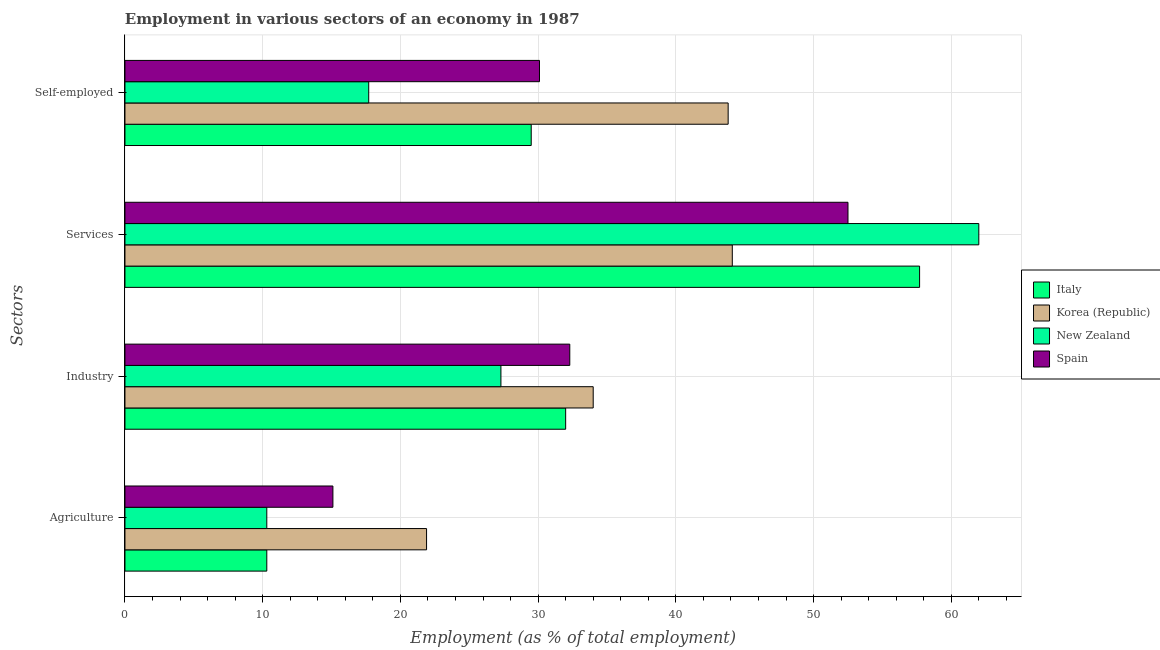Are the number of bars per tick equal to the number of legend labels?
Your answer should be compact. Yes. Are the number of bars on each tick of the Y-axis equal?
Your answer should be compact. Yes. How many bars are there on the 3rd tick from the top?
Provide a succinct answer. 4. How many bars are there on the 3rd tick from the bottom?
Offer a very short reply. 4. What is the label of the 3rd group of bars from the top?
Keep it short and to the point. Industry. What is the percentage of self employed workers in Italy?
Provide a short and direct response. 29.5. Across all countries, what is the maximum percentage of workers in services?
Ensure brevity in your answer.  62. Across all countries, what is the minimum percentage of self employed workers?
Your answer should be very brief. 17.7. In which country was the percentage of self employed workers maximum?
Your answer should be very brief. Korea (Republic). In which country was the percentage of workers in industry minimum?
Your answer should be very brief. New Zealand. What is the total percentage of workers in agriculture in the graph?
Keep it short and to the point. 57.6. What is the difference between the percentage of self employed workers in New Zealand and that in Italy?
Your answer should be very brief. -11.8. What is the difference between the percentage of workers in services in Korea (Republic) and the percentage of workers in agriculture in New Zealand?
Make the answer very short. 33.8. What is the average percentage of workers in agriculture per country?
Provide a succinct answer. 14.4. What is the difference between the percentage of self employed workers and percentage of workers in agriculture in Italy?
Keep it short and to the point. 19.2. In how many countries, is the percentage of workers in industry greater than 14 %?
Your answer should be compact. 4. What is the ratio of the percentage of self employed workers in New Zealand to that in Korea (Republic)?
Give a very brief answer. 0.4. Is the difference between the percentage of self employed workers in Italy and Korea (Republic) greater than the difference between the percentage of workers in services in Italy and Korea (Republic)?
Provide a short and direct response. No. What is the difference between the highest and the second highest percentage of workers in services?
Offer a terse response. 4.3. What is the difference between the highest and the lowest percentage of self employed workers?
Ensure brevity in your answer.  26.1. In how many countries, is the percentage of workers in services greater than the average percentage of workers in services taken over all countries?
Give a very brief answer. 2. Is the sum of the percentage of self employed workers in Spain and Italy greater than the maximum percentage of workers in industry across all countries?
Keep it short and to the point. Yes. What does the 4th bar from the top in Services represents?
Offer a very short reply. Italy. What does the 3rd bar from the bottom in Services represents?
Ensure brevity in your answer.  New Zealand. How many bars are there?
Your answer should be compact. 16. Are all the bars in the graph horizontal?
Make the answer very short. Yes. Are the values on the major ticks of X-axis written in scientific E-notation?
Offer a very short reply. No. Does the graph contain grids?
Ensure brevity in your answer.  Yes. Where does the legend appear in the graph?
Provide a succinct answer. Center right. How many legend labels are there?
Ensure brevity in your answer.  4. What is the title of the graph?
Your answer should be very brief. Employment in various sectors of an economy in 1987. What is the label or title of the X-axis?
Provide a short and direct response. Employment (as % of total employment). What is the label or title of the Y-axis?
Offer a terse response. Sectors. What is the Employment (as % of total employment) of Italy in Agriculture?
Ensure brevity in your answer.  10.3. What is the Employment (as % of total employment) in Korea (Republic) in Agriculture?
Offer a terse response. 21.9. What is the Employment (as % of total employment) in New Zealand in Agriculture?
Keep it short and to the point. 10.3. What is the Employment (as % of total employment) of Spain in Agriculture?
Provide a short and direct response. 15.1. What is the Employment (as % of total employment) in Italy in Industry?
Give a very brief answer. 32. What is the Employment (as % of total employment) in Korea (Republic) in Industry?
Offer a terse response. 34. What is the Employment (as % of total employment) of New Zealand in Industry?
Make the answer very short. 27.3. What is the Employment (as % of total employment) of Spain in Industry?
Your answer should be compact. 32.3. What is the Employment (as % of total employment) in Italy in Services?
Ensure brevity in your answer.  57.7. What is the Employment (as % of total employment) of Korea (Republic) in Services?
Ensure brevity in your answer.  44.1. What is the Employment (as % of total employment) in Spain in Services?
Ensure brevity in your answer.  52.5. What is the Employment (as % of total employment) in Italy in Self-employed?
Make the answer very short. 29.5. What is the Employment (as % of total employment) of Korea (Republic) in Self-employed?
Ensure brevity in your answer.  43.8. What is the Employment (as % of total employment) of New Zealand in Self-employed?
Provide a short and direct response. 17.7. What is the Employment (as % of total employment) of Spain in Self-employed?
Make the answer very short. 30.1. Across all Sectors, what is the maximum Employment (as % of total employment) in Italy?
Offer a terse response. 57.7. Across all Sectors, what is the maximum Employment (as % of total employment) of Korea (Republic)?
Your answer should be very brief. 44.1. Across all Sectors, what is the maximum Employment (as % of total employment) of New Zealand?
Give a very brief answer. 62. Across all Sectors, what is the maximum Employment (as % of total employment) in Spain?
Give a very brief answer. 52.5. Across all Sectors, what is the minimum Employment (as % of total employment) of Italy?
Your response must be concise. 10.3. Across all Sectors, what is the minimum Employment (as % of total employment) of Korea (Republic)?
Provide a short and direct response. 21.9. Across all Sectors, what is the minimum Employment (as % of total employment) of New Zealand?
Your response must be concise. 10.3. Across all Sectors, what is the minimum Employment (as % of total employment) in Spain?
Offer a very short reply. 15.1. What is the total Employment (as % of total employment) of Italy in the graph?
Give a very brief answer. 129.5. What is the total Employment (as % of total employment) in Korea (Republic) in the graph?
Make the answer very short. 143.8. What is the total Employment (as % of total employment) in New Zealand in the graph?
Offer a very short reply. 117.3. What is the total Employment (as % of total employment) in Spain in the graph?
Your answer should be very brief. 130. What is the difference between the Employment (as % of total employment) of Italy in Agriculture and that in Industry?
Offer a very short reply. -21.7. What is the difference between the Employment (as % of total employment) of Korea (Republic) in Agriculture and that in Industry?
Make the answer very short. -12.1. What is the difference between the Employment (as % of total employment) in New Zealand in Agriculture and that in Industry?
Offer a terse response. -17. What is the difference between the Employment (as % of total employment) of Spain in Agriculture and that in Industry?
Your answer should be very brief. -17.2. What is the difference between the Employment (as % of total employment) of Italy in Agriculture and that in Services?
Give a very brief answer. -47.4. What is the difference between the Employment (as % of total employment) in Korea (Republic) in Agriculture and that in Services?
Ensure brevity in your answer.  -22.2. What is the difference between the Employment (as % of total employment) of New Zealand in Agriculture and that in Services?
Keep it short and to the point. -51.7. What is the difference between the Employment (as % of total employment) in Spain in Agriculture and that in Services?
Provide a short and direct response. -37.4. What is the difference between the Employment (as % of total employment) of Italy in Agriculture and that in Self-employed?
Keep it short and to the point. -19.2. What is the difference between the Employment (as % of total employment) of Korea (Republic) in Agriculture and that in Self-employed?
Offer a very short reply. -21.9. What is the difference between the Employment (as % of total employment) of Spain in Agriculture and that in Self-employed?
Keep it short and to the point. -15. What is the difference between the Employment (as % of total employment) in Italy in Industry and that in Services?
Offer a terse response. -25.7. What is the difference between the Employment (as % of total employment) in Korea (Republic) in Industry and that in Services?
Ensure brevity in your answer.  -10.1. What is the difference between the Employment (as % of total employment) in New Zealand in Industry and that in Services?
Offer a terse response. -34.7. What is the difference between the Employment (as % of total employment) in Spain in Industry and that in Services?
Offer a very short reply. -20.2. What is the difference between the Employment (as % of total employment) in Korea (Republic) in Industry and that in Self-employed?
Offer a terse response. -9.8. What is the difference between the Employment (as % of total employment) of Spain in Industry and that in Self-employed?
Give a very brief answer. 2.2. What is the difference between the Employment (as % of total employment) of Italy in Services and that in Self-employed?
Make the answer very short. 28.2. What is the difference between the Employment (as % of total employment) of Korea (Republic) in Services and that in Self-employed?
Your response must be concise. 0.3. What is the difference between the Employment (as % of total employment) in New Zealand in Services and that in Self-employed?
Give a very brief answer. 44.3. What is the difference between the Employment (as % of total employment) of Spain in Services and that in Self-employed?
Provide a short and direct response. 22.4. What is the difference between the Employment (as % of total employment) of Italy in Agriculture and the Employment (as % of total employment) of Korea (Republic) in Industry?
Make the answer very short. -23.7. What is the difference between the Employment (as % of total employment) in Korea (Republic) in Agriculture and the Employment (as % of total employment) in New Zealand in Industry?
Your answer should be compact. -5.4. What is the difference between the Employment (as % of total employment) in New Zealand in Agriculture and the Employment (as % of total employment) in Spain in Industry?
Provide a succinct answer. -22. What is the difference between the Employment (as % of total employment) of Italy in Agriculture and the Employment (as % of total employment) of Korea (Republic) in Services?
Provide a short and direct response. -33.8. What is the difference between the Employment (as % of total employment) in Italy in Agriculture and the Employment (as % of total employment) in New Zealand in Services?
Provide a short and direct response. -51.7. What is the difference between the Employment (as % of total employment) in Italy in Agriculture and the Employment (as % of total employment) in Spain in Services?
Your answer should be very brief. -42.2. What is the difference between the Employment (as % of total employment) in Korea (Republic) in Agriculture and the Employment (as % of total employment) in New Zealand in Services?
Offer a very short reply. -40.1. What is the difference between the Employment (as % of total employment) of Korea (Republic) in Agriculture and the Employment (as % of total employment) of Spain in Services?
Your answer should be compact. -30.6. What is the difference between the Employment (as % of total employment) in New Zealand in Agriculture and the Employment (as % of total employment) in Spain in Services?
Offer a terse response. -42.2. What is the difference between the Employment (as % of total employment) in Italy in Agriculture and the Employment (as % of total employment) in Korea (Republic) in Self-employed?
Give a very brief answer. -33.5. What is the difference between the Employment (as % of total employment) in Italy in Agriculture and the Employment (as % of total employment) in New Zealand in Self-employed?
Offer a terse response. -7.4. What is the difference between the Employment (as % of total employment) of Italy in Agriculture and the Employment (as % of total employment) of Spain in Self-employed?
Keep it short and to the point. -19.8. What is the difference between the Employment (as % of total employment) of Korea (Republic) in Agriculture and the Employment (as % of total employment) of New Zealand in Self-employed?
Keep it short and to the point. 4.2. What is the difference between the Employment (as % of total employment) in Korea (Republic) in Agriculture and the Employment (as % of total employment) in Spain in Self-employed?
Your answer should be very brief. -8.2. What is the difference between the Employment (as % of total employment) of New Zealand in Agriculture and the Employment (as % of total employment) of Spain in Self-employed?
Your answer should be compact. -19.8. What is the difference between the Employment (as % of total employment) in Italy in Industry and the Employment (as % of total employment) in Korea (Republic) in Services?
Offer a very short reply. -12.1. What is the difference between the Employment (as % of total employment) in Italy in Industry and the Employment (as % of total employment) in New Zealand in Services?
Your answer should be very brief. -30. What is the difference between the Employment (as % of total employment) of Italy in Industry and the Employment (as % of total employment) of Spain in Services?
Make the answer very short. -20.5. What is the difference between the Employment (as % of total employment) in Korea (Republic) in Industry and the Employment (as % of total employment) in New Zealand in Services?
Provide a succinct answer. -28. What is the difference between the Employment (as % of total employment) in Korea (Republic) in Industry and the Employment (as % of total employment) in Spain in Services?
Your response must be concise. -18.5. What is the difference between the Employment (as % of total employment) in New Zealand in Industry and the Employment (as % of total employment) in Spain in Services?
Your response must be concise. -25.2. What is the difference between the Employment (as % of total employment) in Italy in Industry and the Employment (as % of total employment) in Korea (Republic) in Self-employed?
Provide a short and direct response. -11.8. What is the difference between the Employment (as % of total employment) in Italy in Industry and the Employment (as % of total employment) in New Zealand in Self-employed?
Your answer should be very brief. 14.3. What is the difference between the Employment (as % of total employment) in Italy in Industry and the Employment (as % of total employment) in Spain in Self-employed?
Offer a terse response. 1.9. What is the difference between the Employment (as % of total employment) in Korea (Republic) in Industry and the Employment (as % of total employment) in New Zealand in Self-employed?
Ensure brevity in your answer.  16.3. What is the difference between the Employment (as % of total employment) of Korea (Republic) in Industry and the Employment (as % of total employment) of Spain in Self-employed?
Your answer should be compact. 3.9. What is the difference between the Employment (as % of total employment) of New Zealand in Industry and the Employment (as % of total employment) of Spain in Self-employed?
Keep it short and to the point. -2.8. What is the difference between the Employment (as % of total employment) in Italy in Services and the Employment (as % of total employment) in Korea (Republic) in Self-employed?
Provide a short and direct response. 13.9. What is the difference between the Employment (as % of total employment) in Italy in Services and the Employment (as % of total employment) in Spain in Self-employed?
Your answer should be compact. 27.6. What is the difference between the Employment (as % of total employment) of Korea (Republic) in Services and the Employment (as % of total employment) of New Zealand in Self-employed?
Your answer should be very brief. 26.4. What is the difference between the Employment (as % of total employment) in Korea (Republic) in Services and the Employment (as % of total employment) in Spain in Self-employed?
Give a very brief answer. 14. What is the difference between the Employment (as % of total employment) in New Zealand in Services and the Employment (as % of total employment) in Spain in Self-employed?
Your response must be concise. 31.9. What is the average Employment (as % of total employment) in Italy per Sectors?
Offer a terse response. 32.38. What is the average Employment (as % of total employment) of Korea (Republic) per Sectors?
Ensure brevity in your answer.  35.95. What is the average Employment (as % of total employment) in New Zealand per Sectors?
Offer a very short reply. 29.32. What is the average Employment (as % of total employment) in Spain per Sectors?
Your answer should be compact. 32.5. What is the difference between the Employment (as % of total employment) of Italy and Employment (as % of total employment) of Korea (Republic) in Agriculture?
Ensure brevity in your answer.  -11.6. What is the difference between the Employment (as % of total employment) of Italy and Employment (as % of total employment) of New Zealand in Agriculture?
Keep it short and to the point. 0. What is the difference between the Employment (as % of total employment) in Korea (Republic) and Employment (as % of total employment) in New Zealand in Agriculture?
Keep it short and to the point. 11.6. What is the difference between the Employment (as % of total employment) in Korea (Republic) and Employment (as % of total employment) in Spain in Agriculture?
Ensure brevity in your answer.  6.8. What is the difference between the Employment (as % of total employment) in New Zealand and Employment (as % of total employment) in Spain in Agriculture?
Give a very brief answer. -4.8. What is the difference between the Employment (as % of total employment) in Italy and Employment (as % of total employment) in New Zealand in Industry?
Offer a very short reply. 4.7. What is the difference between the Employment (as % of total employment) of Italy and Employment (as % of total employment) of Spain in Industry?
Provide a succinct answer. -0.3. What is the difference between the Employment (as % of total employment) in Korea (Republic) and Employment (as % of total employment) in New Zealand in Industry?
Your answer should be very brief. 6.7. What is the difference between the Employment (as % of total employment) in New Zealand and Employment (as % of total employment) in Spain in Industry?
Offer a very short reply. -5. What is the difference between the Employment (as % of total employment) of Italy and Employment (as % of total employment) of Korea (Republic) in Services?
Offer a very short reply. 13.6. What is the difference between the Employment (as % of total employment) in Italy and Employment (as % of total employment) in Spain in Services?
Offer a very short reply. 5.2. What is the difference between the Employment (as % of total employment) of Korea (Republic) and Employment (as % of total employment) of New Zealand in Services?
Your answer should be compact. -17.9. What is the difference between the Employment (as % of total employment) in Korea (Republic) and Employment (as % of total employment) in Spain in Services?
Your response must be concise. -8.4. What is the difference between the Employment (as % of total employment) in Italy and Employment (as % of total employment) in Korea (Republic) in Self-employed?
Make the answer very short. -14.3. What is the difference between the Employment (as % of total employment) in Italy and Employment (as % of total employment) in New Zealand in Self-employed?
Give a very brief answer. 11.8. What is the difference between the Employment (as % of total employment) in Italy and Employment (as % of total employment) in Spain in Self-employed?
Ensure brevity in your answer.  -0.6. What is the difference between the Employment (as % of total employment) in Korea (Republic) and Employment (as % of total employment) in New Zealand in Self-employed?
Your answer should be compact. 26.1. What is the difference between the Employment (as % of total employment) of Korea (Republic) and Employment (as % of total employment) of Spain in Self-employed?
Your answer should be very brief. 13.7. What is the ratio of the Employment (as % of total employment) of Italy in Agriculture to that in Industry?
Ensure brevity in your answer.  0.32. What is the ratio of the Employment (as % of total employment) of Korea (Republic) in Agriculture to that in Industry?
Ensure brevity in your answer.  0.64. What is the ratio of the Employment (as % of total employment) of New Zealand in Agriculture to that in Industry?
Your response must be concise. 0.38. What is the ratio of the Employment (as % of total employment) in Spain in Agriculture to that in Industry?
Give a very brief answer. 0.47. What is the ratio of the Employment (as % of total employment) of Italy in Agriculture to that in Services?
Your answer should be very brief. 0.18. What is the ratio of the Employment (as % of total employment) of Korea (Republic) in Agriculture to that in Services?
Provide a succinct answer. 0.5. What is the ratio of the Employment (as % of total employment) in New Zealand in Agriculture to that in Services?
Provide a short and direct response. 0.17. What is the ratio of the Employment (as % of total employment) in Spain in Agriculture to that in Services?
Your response must be concise. 0.29. What is the ratio of the Employment (as % of total employment) in Italy in Agriculture to that in Self-employed?
Make the answer very short. 0.35. What is the ratio of the Employment (as % of total employment) in Korea (Republic) in Agriculture to that in Self-employed?
Your answer should be compact. 0.5. What is the ratio of the Employment (as % of total employment) in New Zealand in Agriculture to that in Self-employed?
Your response must be concise. 0.58. What is the ratio of the Employment (as % of total employment) in Spain in Agriculture to that in Self-employed?
Provide a succinct answer. 0.5. What is the ratio of the Employment (as % of total employment) of Italy in Industry to that in Services?
Your response must be concise. 0.55. What is the ratio of the Employment (as % of total employment) of Korea (Republic) in Industry to that in Services?
Your answer should be compact. 0.77. What is the ratio of the Employment (as % of total employment) of New Zealand in Industry to that in Services?
Provide a succinct answer. 0.44. What is the ratio of the Employment (as % of total employment) of Spain in Industry to that in Services?
Ensure brevity in your answer.  0.62. What is the ratio of the Employment (as % of total employment) of Italy in Industry to that in Self-employed?
Provide a succinct answer. 1.08. What is the ratio of the Employment (as % of total employment) of Korea (Republic) in Industry to that in Self-employed?
Your answer should be compact. 0.78. What is the ratio of the Employment (as % of total employment) in New Zealand in Industry to that in Self-employed?
Keep it short and to the point. 1.54. What is the ratio of the Employment (as % of total employment) of Spain in Industry to that in Self-employed?
Your response must be concise. 1.07. What is the ratio of the Employment (as % of total employment) in Italy in Services to that in Self-employed?
Your response must be concise. 1.96. What is the ratio of the Employment (as % of total employment) of Korea (Republic) in Services to that in Self-employed?
Offer a terse response. 1.01. What is the ratio of the Employment (as % of total employment) in New Zealand in Services to that in Self-employed?
Provide a succinct answer. 3.5. What is the ratio of the Employment (as % of total employment) of Spain in Services to that in Self-employed?
Your answer should be very brief. 1.74. What is the difference between the highest and the second highest Employment (as % of total employment) of Italy?
Make the answer very short. 25.7. What is the difference between the highest and the second highest Employment (as % of total employment) in Korea (Republic)?
Your response must be concise. 0.3. What is the difference between the highest and the second highest Employment (as % of total employment) of New Zealand?
Your answer should be compact. 34.7. What is the difference between the highest and the second highest Employment (as % of total employment) in Spain?
Provide a short and direct response. 20.2. What is the difference between the highest and the lowest Employment (as % of total employment) in Italy?
Your answer should be very brief. 47.4. What is the difference between the highest and the lowest Employment (as % of total employment) of Korea (Republic)?
Your answer should be very brief. 22.2. What is the difference between the highest and the lowest Employment (as % of total employment) in New Zealand?
Provide a succinct answer. 51.7. What is the difference between the highest and the lowest Employment (as % of total employment) of Spain?
Offer a terse response. 37.4. 